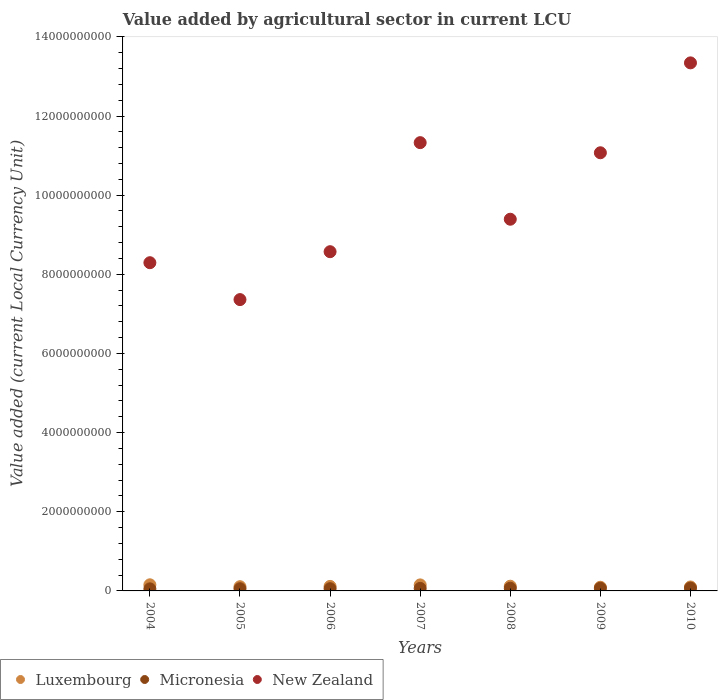How many different coloured dotlines are there?
Make the answer very short. 3. Is the number of dotlines equal to the number of legend labels?
Provide a short and direct response. Yes. What is the value added by agricultural sector in Micronesia in 2005?
Ensure brevity in your answer.  5.58e+07. Across all years, what is the maximum value added by agricultural sector in New Zealand?
Your answer should be very brief. 1.33e+1. Across all years, what is the minimum value added by agricultural sector in Luxembourg?
Your answer should be very brief. 9.30e+07. In which year was the value added by agricultural sector in Luxembourg maximum?
Your response must be concise. 2004. In which year was the value added by agricultural sector in Micronesia minimum?
Provide a short and direct response. 2004. What is the total value added by agricultural sector in Micronesia in the graph?
Give a very brief answer. 4.36e+08. What is the difference between the value added by agricultural sector in Micronesia in 2005 and that in 2006?
Your answer should be very brief. -9.00e+05. What is the difference between the value added by agricultural sector in Micronesia in 2005 and the value added by agricultural sector in New Zealand in 2007?
Provide a succinct answer. -1.13e+1. What is the average value added by agricultural sector in New Zealand per year?
Give a very brief answer. 9.91e+09. In the year 2007, what is the difference between the value added by agricultural sector in New Zealand and value added by agricultural sector in Micronesia?
Provide a succinct answer. 1.13e+1. In how many years, is the value added by agricultural sector in Micronesia greater than 5200000000 LCU?
Provide a short and direct response. 0. What is the ratio of the value added by agricultural sector in Micronesia in 2005 to that in 2008?
Your response must be concise. 0.82. What is the difference between the highest and the second highest value added by agricultural sector in Micronesia?
Ensure brevity in your answer.  2.90e+06. What is the difference between the highest and the lowest value added by agricultural sector in Luxembourg?
Your answer should be compact. 6.18e+07. In how many years, is the value added by agricultural sector in Luxembourg greater than the average value added by agricultural sector in Luxembourg taken over all years?
Your answer should be compact. 2. Does the value added by agricultural sector in Micronesia monotonically increase over the years?
Give a very brief answer. Yes. Is the value added by agricultural sector in Luxembourg strictly greater than the value added by agricultural sector in New Zealand over the years?
Ensure brevity in your answer.  No. How many dotlines are there?
Make the answer very short. 3. How many years are there in the graph?
Offer a terse response. 7. What is the difference between two consecutive major ticks on the Y-axis?
Give a very brief answer. 2.00e+09. Where does the legend appear in the graph?
Make the answer very short. Bottom left. What is the title of the graph?
Make the answer very short. Value added by agricultural sector in current LCU. What is the label or title of the Y-axis?
Give a very brief answer. Value added (current Local Currency Unit). What is the Value added (current Local Currency Unit) of Luxembourg in 2004?
Make the answer very short. 1.55e+08. What is the Value added (current Local Currency Unit) in Micronesia in 2004?
Make the answer very short. 5.26e+07. What is the Value added (current Local Currency Unit) of New Zealand in 2004?
Offer a very short reply. 8.29e+09. What is the Value added (current Local Currency Unit) of Luxembourg in 2005?
Provide a succinct answer. 1.07e+08. What is the Value added (current Local Currency Unit) of Micronesia in 2005?
Provide a succinct answer. 5.58e+07. What is the Value added (current Local Currency Unit) of New Zealand in 2005?
Your answer should be very brief. 7.36e+09. What is the Value added (current Local Currency Unit) of Luxembourg in 2006?
Provide a succinct answer. 1.14e+08. What is the Value added (current Local Currency Unit) of Micronesia in 2006?
Make the answer very short. 5.67e+07. What is the Value added (current Local Currency Unit) in New Zealand in 2006?
Provide a short and direct response. 8.57e+09. What is the Value added (current Local Currency Unit) of Luxembourg in 2007?
Keep it short and to the point. 1.52e+08. What is the Value added (current Local Currency Unit) in Micronesia in 2007?
Your answer should be compact. 6.37e+07. What is the Value added (current Local Currency Unit) in New Zealand in 2007?
Your answer should be compact. 1.13e+1. What is the Value added (current Local Currency Unit) in Luxembourg in 2008?
Ensure brevity in your answer.  1.19e+08. What is the Value added (current Local Currency Unit) in Micronesia in 2008?
Your answer should be very brief. 6.79e+07. What is the Value added (current Local Currency Unit) of New Zealand in 2008?
Your answer should be compact. 9.39e+09. What is the Value added (current Local Currency Unit) in Luxembourg in 2009?
Give a very brief answer. 9.30e+07. What is the Value added (current Local Currency Unit) of Micronesia in 2009?
Provide a succinct answer. 6.84e+07. What is the Value added (current Local Currency Unit) in New Zealand in 2009?
Give a very brief answer. 1.11e+1. What is the Value added (current Local Currency Unit) of Micronesia in 2010?
Offer a terse response. 7.13e+07. What is the Value added (current Local Currency Unit) of New Zealand in 2010?
Provide a short and direct response. 1.33e+1. Across all years, what is the maximum Value added (current Local Currency Unit) in Luxembourg?
Provide a short and direct response. 1.55e+08. Across all years, what is the maximum Value added (current Local Currency Unit) of Micronesia?
Your answer should be compact. 7.13e+07. Across all years, what is the maximum Value added (current Local Currency Unit) in New Zealand?
Your answer should be very brief. 1.33e+1. Across all years, what is the minimum Value added (current Local Currency Unit) of Luxembourg?
Your response must be concise. 9.30e+07. Across all years, what is the minimum Value added (current Local Currency Unit) in Micronesia?
Offer a very short reply. 5.26e+07. Across all years, what is the minimum Value added (current Local Currency Unit) in New Zealand?
Offer a very short reply. 7.36e+09. What is the total Value added (current Local Currency Unit) in Luxembourg in the graph?
Provide a succinct answer. 8.40e+08. What is the total Value added (current Local Currency Unit) of Micronesia in the graph?
Offer a very short reply. 4.36e+08. What is the total Value added (current Local Currency Unit) in New Zealand in the graph?
Provide a succinct answer. 6.94e+1. What is the difference between the Value added (current Local Currency Unit) of Luxembourg in 2004 and that in 2005?
Make the answer very short. 4.80e+07. What is the difference between the Value added (current Local Currency Unit) of Micronesia in 2004 and that in 2005?
Your answer should be compact. -3.20e+06. What is the difference between the Value added (current Local Currency Unit) in New Zealand in 2004 and that in 2005?
Ensure brevity in your answer.  9.32e+08. What is the difference between the Value added (current Local Currency Unit) of Luxembourg in 2004 and that in 2006?
Offer a terse response. 4.05e+07. What is the difference between the Value added (current Local Currency Unit) of Micronesia in 2004 and that in 2006?
Offer a very short reply. -4.10e+06. What is the difference between the Value added (current Local Currency Unit) of New Zealand in 2004 and that in 2006?
Provide a short and direct response. -2.78e+08. What is the difference between the Value added (current Local Currency Unit) in Luxembourg in 2004 and that in 2007?
Provide a succinct answer. 2.50e+06. What is the difference between the Value added (current Local Currency Unit) of Micronesia in 2004 and that in 2007?
Provide a succinct answer. -1.11e+07. What is the difference between the Value added (current Local Currency Unit) of New Zealand in 2004 and that in 2007?
Provide a short and direct response. -3.03e+09. What is the difference between the Value added (current Local Currency Unit) of Luxembourg in 2004 and that in 2008?
Keep it short and to the point. 3.59e+07. What is the difference between the Value added (current Local Currency Unit) of Micronesia in 2004 and that in 2008?
Offer a terse response. -1.53e+07. What is the difference between the Value added (current Local Currency Unit) of New Zealand in 2004 and that in 2008?
Keep it short and to the point. -1.10e+09. What is the difference between the Value added (current Local Currency Unit) in Luxembourg in 2004 and that in 2009?
Make the answer very short. 6.18e+07. What is the difference between the Value added (current Local Currency Unit) of Micronesia in 2004 and that in 2009?
Your response must be concise. -1.58e+07. What is the difference between the Value added (current Local Currency Unit) in New Zealand in 2004 and that in 2009?
Provide a short and direct response. -2.78e+09. What is the difference between the Value added (current Local Currency Unit) of Luxembourg in 2004 and that in 2010?
Provide a succinct answer. 5.48e+07. What is the difference between the Value added (current Local Currency Unit) in Micronesia in 2004 and that in 2010?
Your response must be concise. -1.87e+07. What is the difference between the Value added (current Local Currency Unit) in New Zealand in 2004 and that in 2010?
Your answer should be compact. -5.05e+09. What is the difference between the Value added (current Local Currency Unit) of Luxembourg in 2005 and that in 2006?
Offer a very short reply. -7.50e+06. What is the difference between the Value added (current Local Currency Unit) in Micronesia in 2005 and that in 2006?
Provide a succinct answer. -9.00e+05. What is the difference between the Value added (current Local Currency Unit) of New Zealand in 2005 and that in 2006?
Your response must be concise. -1.21e+09. What is the difference between the Value added (current Local Currency Unit) of Luxembourg in 2005 and that in 2007?
Your response must be concise. -4.55e+07. What is the difference between the Value added (current Local Currency Unit) of Micronesia in 2005 and that in 2007?
Keep it short and to the point. -7.90e+06. What is the difference between the Value added (current Local Currency Unit) of New Zealand in 2005 and that in 2007?
Make the answer very short. -3.97e+09. What is the difference between the Value added (current Local Currency Unit) of Luxembourg in 2005 and that in 2008?
Ensure brevity in your answer.  -1.21e+07. What is the difference between the Value added (current Local Currency Unit) in Micronesia in 2005 and that in 2008?
Ensure brevity in your answer.  -1.21e+07. What is the difference between the Value added (current Local Currency Unit) of New Zealand in 2005 and that in 2008?
Offer a terse response. -2.03e+09. What is the difference between the Value added (current Local Currency Unit) in Luxembourg in 2005 and that in 2009?
Your answer should be very brief. 1.38e+07. What is the difference between the Value added (current Local Currency Unit) in Micronesia in 2005 and that in 2009?
Your response must be concise. -1.26e+07. What is the difference between the Value added (current Local Currency Unit) of New Zealand in 2005 and that in 2009?
Give a very brief answer. -3.71e+09. What is the difference between the Value added (current Local Currency Unit) in Luxembourg in 2005 and that in 2010?
Offer a terse response. 6.80e+06. What is the difference between the Value added (current Local Currency Unit) of Micronesia in 2005 and that in 2010?
Give a very brief answer. -1.55e+07. What is the difference between the Value added (current Local Currency Unit) of New Zealand in 2005 and that in 2010?
Make the answer very short. -5.98e+09. What is the difference between the Value added (current Local Currency Unit) of Luxembourg in 2006 and that in 2007?
Offer a terse response. -3.80e+07. What is the difference between the Value added (current Local Currency Unit) in Micronesia in 2006 and that in 2007?
Give a very brief answer. -7.00e+06. What is the difference between the Value added (current Local Currency Unit) in New Zealand in 2006 and that in 2007?
Provide a succinct answer. -2.76e+09. What is the difference between the Value added (current Local Currency Unit) of Luxembourg in 2006 and that in 2008?
Your answer should be very brief. -4.60e+06. What is the difference between the Value added (current Local Currency Unit) of Micronesia in 2006 and that in 2008?
Offer a very short reply. -1.12e+07. What is the difference between the Value added (current Local Currency Unit) of New Zealand in 2006 and that in 2008?
Your answer should be compact. -8.20e+08. What is the difference between the Value added (current Local Currency Unit) of Luxembourg in 2006 and that in 2009?
Your answer should be compact. 2.13e+07. What is the difference between the Value added (current Local Currency Unit) in Micronesia in 2006 and that in 2009?
Provide a short and direct response. -1.17e+07. What is the difference between the Value added (current Local Currency Unit) of New Zealand in 2006 and that in 2009?
Your answer should be very brief. -2.50e+09. What is the difference between the Value added (current Local Currency Unit) in Luxembourg in 2006 and that in 2010?
Your answer should be very brief. 1.43e+07. What is the difference between the Value added (current Local Currency Unit) of Micronesia in 2006 and that in 2010?
Give a very brief answer. -1.46e+07. What is the difference between the Value added (current Local Currency Unit) in New Zealand in 2006 and that in 2010?
Your response must be concise. -4.77e+09. What is the difference between the Value added (current Local Currency Unit) of Luxembourg in 2007 and that in 2008?
Your response must be concise. 3.34e+07. What is the difference between the Value added (current Local Currency Unit) of Micronesia in 2007 and that in 2008?
Your answer should be very brief. -4.20e+06. What is the difference between the Value added (current Local Currency Unit) in New Zealand in 2007 and that in 2008?
Keep it short and to the point. 1.94e+09. What is the difference between the Value added (current Local Currency Unit) of Luxembourg in 2007 and that in 2009?
Offer a terse response. 5.93e+07. What is the difference between the Value added (current Local Currency Unit) in Micronesia in 2007 and that in 2009?
Your response must be concise. -4.70e+06. What is the difference between the Value added (current Local Currency Unit) of New Zealand in 2007 and that in 2009?
Keep it short and to the point. 2.56e+08. What is the difference between the Value added (current Local Currency Unit) in Luxembourg in 2007 and that in 2010?
Provide a short and direct response. 5.23e+07. What is the difference between the Value added (current Local Currency Unit) of Micronesia in 2007 and that in 2010?
Keep it short and to the point. -7.60e+06. What is the difference between the Value added (current Local Currency Unit) in New Zealand in 2007 and that in 2010?
Give a very brief answer. -2.02e+09. What is the difference between the Value added (current Local Currency Unit) of Luxembourg in 2008 and that in 2009?
Make the answer very short. 2.59e+07. What is the difference between the Value added (current Local Currency Unit) of Micronesia in 2008 and that in 2009?
Offer a very short reply. -5.00e+05. What is the difference between the Value added (current Local Currency Unit) in New Zealand in 2008 and that in 2009?
Make the answer very short. -1.68e+09. What is the difference between the Value added (current Local Currency Unit) of Luxembourg in 2008 and that in 2010?
Your response must be concise. 1.89e+07. What is the difference between the Value added (current Local Currency Unit) in Micronesia in 2008 and that in 2010?
Give a very brief answer. -3.40e+06. What is the difference between the Value added (current Local Currency Unit) of New Zealand in 2008 and that in 2010?
Provide a succinct answer. -3.95e+09. What is the difference between the Value added (current Local Currency Unit) of Luxembourg in 2009 and that in 2010?
Your answer should be compact. -7.00e+06. What is the difference between the Value added (current Local Currency Unit) of Micronesia in 2009 and that in 2010?
Offer a terse response. -2.90e+06. What is the difference between the Value added (current Local Currency Unit) in New Zealand in 2009 and that in 2010?
Provide a succinct answer. -2.27e+09. What is the difference between the Value added (current Local Currency Unit) of Luxembourg in 2004 and the Value added (current Local Currency Unit) of Micronesia in 2005?
Provide a short and direct response. 9.90e+07. What is the difference between the Value added (current Local Currency Unit) in Luxembourg in 2004 and the Value added (current Local Currency Unit) in New Zealand in 2005?
Your answer should be compact. -7.21e+09. What is the difference between the Value added (current Local Currency Unit) of Micronesia in 2004 and the Value added (current Local Currency Unit) of New Zealand in 2005?
Your response must be concise. -7.31e+09. What is the difference between the Value added (current Local Currency Unit) of Luxembourg in 2004 and the Value added (current Local Currency Unit) of Micronesia in 2006?
Provide a succinct answer. 9.81e+07. What is the difference between the Value added (current Local Currency Unit) of Luxembourg in 2004 and the Value added (current Local Currency Unit) of New Zealand in 2006?
Offer a terse response. -8.42e+09. What is the difference between the Value added (current Local Currency Unit) in Micronesia in 2004 and the Value added (current Local Currency Unit) in New Zealand in 2006?
Make the answer very short. -8.52e+09. What is the difference between the Value added (current Local Currency Unit) of Luxembourg in 2004 and the Value added (current Local Currency Unit) of Micronesia in 2007?
Offer a terse response. 9.11e+07. What is the difference between the Value added (current Local Currency Unit) in Luxembourg in 2004 and the Value added (current Local Currency Unit) in New Zealand in 2007?
Ensure brevity in your answer.  -1.12e+1. What is the difference between the Value added (current Local Currency Unit) in Micronesia in 2004 and the Value added (current Local Currency Unit) in New Zealand in 2007?
Your response must be concise. -1.13e+1. What is the difference between the Value added (current Local Currency Unit) in Luxembourg in 2004 and the Value added (current Local Currency Unit) in Micronesia in 2008?
Offer a very short reply. 8.69e+07. What is the difference between the Value added (current Local Currency Unit) in Luxembourg in 2004 and the Value added (current Local Currency Unit) in New Zealand in 2008?
Make the answer very short. -9.24e+09. What is the difference between the Value added (current Local Currency Unit) of Micronesia in 2004 and the Value added (current Local Currency Unit) of New Zealand in 2008?
Your answer should be compact. -9.34e+09. What is the difference between the Value added (current Local Currency Unit) of Luxembourg in 2004 and the Value added (current Local Currency Unit) of Micronesia in 2009?
Offer a terse response. 8.64e+07. What is the difference between the Value added (current Local Currency Unit) in Luxembourg in 2004 and the Value added (current Local Currency Unit) in New Zealand in 2009?
Provide a short and direct response. -1.09e+1. What is the difference between the Value added (current Local Currency Unit) in Micronesia in 2004 and the Value added (current Local Currency Unit) in New Zealand in 2009?
Make the answer very short. -1.10e+1. What is the difference between the Value added (current Local Currency Unit) of Luxembourg in 2004 and the Value added (current Local Currency Unit) of Micronesia in 2010?
Your answer should be very brief. 8.35e+07. What is the difference between the Value added (current Local Currency Unit) in Luxembourg in 2004 and the Value added (current Local Currency Unit) in New Zealand in 2010?
Ensure brevity in your answer.  -1.32e+1. What is the difference between the Value added (current Local Currency Unit) in Micronesia in 2004 and the Value added (current Local Currency Unit) in New Zealand in 2010?
Give a very brief answer. -1.33e+1. What is the difference between the Value added (current Local Currency Unit) of Luxembourg in 2005 and the Value added (current Local Currency Unit) of Micronesia in 2006?
Your response must be concise. 5.01e+07. What is the difference between the Value added (current Local Currency Unit) of Luxembourg in 2005 and the Value added (current Local Currency Unit) of New Zealand in 2006?
Ensure brevity in your answer.  -8.46e+09. What is the difference between the Value added (current Local Currency Unit) in Micronesia in 2005 and the Value added (current Local Currency Unit) in New Zealand in 2006?
Provide a succinct answer. -8.52e+09. What is the difference between the Value added (current Local Currency Unit) of Luxembourg in 2005 and the Value added (current Local Currency Unit) of Micronesia in 2007?
Ensure brevity in your answer.  4.31e+07. What is the difference between the Value added (current Local Currency Unit) in Luxembourg in 2005 and the Value added (current Local Currency Unit) in New Zealand in 2007?
Keep it short and to the point. -1.12e+1. What is the difference between the Value added (current Local Currency Unit) of Micronesia in 2005 and the Value added (current Local Currency Unit) of New Zealand in 2007?
Provide a succinct answer. -1.13e+1. What is the difference between the Value added (current Local Currency Unit) in Luxembourg in 2005 and the Value added (current Local Currency Unit) in Micronesia in 2008?
Keep it short and to the point. 3.89e+07. What is the difference between the Value added (current Local Currency Unit) in Luxembourg in 2005 and the Value added (current Local Currency Unit) in New Zealand in 2008?
Offer a terse response. -9.29e+09. What is the difference between the Value added (current Local Currency Unit) in Micronesia in 2005 and the Value added (current Local Currency Unit) in New Zealand in 2008?
Your answer should be very brief. -9.34e+09. What is the difference between the Value added (current Local Currency Unit) in Luxembourg in 2005 and the Value added (current Local Currency Unit) in Micronesia in 2009?
Offer a terse response. 3.84e+07. What is the difference between the Value added (current Local Currency Unit) in Luxembourg in 2005 and the Value added (current Local Currency Unit) in New Zealand in 2009?
Make the answer very short. -1.10e+1. What is the difference between the Value added (current Local Currency Unit) in Micronesia in 2005 and the Value added (current Local Currency Unit) in New Zealand in 2009?
Give a very brief answer. -1.10e+1. What is the difference between the Value added (current Local Currency Unit) in Luxembourg in 2005 and the Value added (current Local Currency Unit) in Micronesia in 2010?
Keep it short and to the point. 3.55e+07. What is the difference between the Value added (current Local Currency Unit) in Luxembourg in 2005 and the Value added (current Local Currency Unit) in New Zealand in 2010?
Ensure brevity in your answer.  -1.32e+1. What is the difference between the Value added (current Local Currency Unit) of Micronesia in 2005 and the Value added (current Local Currency Unit) of New Zealand in 2010?
Offer a very short reply. -1.33e+1. What is the difference between the Value added (current Local Currency Unit) in Luxembourg in 2006 and the Value added (current Local Currency Unit) in Micronesia in 2007?
Provide a short and direct response. 5.06e+07. What is the difference between the Value added (current Local Currency Unit) of Luxembourg in 2006 and the Value added (current Local Currency Unit) of New Zealand in 2007?
Your response must be concise. -1.12e+1. What is the difference between the Value added (current Local Currency Unit) in Micronesia in 2006 and the Value added (current Local Currency Unit) in New Zealand in 2007?
Ensure brevity in your answer.  -1.13e+1. What is the difference between the Value added (current Local Currency Unit) in Luxembourg in 2006 and the Value added (current Local Currency Unit) in Micronesia in 2008?
Provide a short and direct response. 4.64e+07. What is the difference between the Value added (current Local Currency Unit) of Luxembourg in 2006 and the Value added (current Local Currency Unit) of New Zealand in 2008?
Offer a terse response. -9.28e+09. What is the difference between the Value added (current Local Currency Unit) in Micronesia in 2006 and the Value added (current Local Currency Unit) in New Zealand in 2008?
Ensure brevity in your answer.  -9.34e+09. What is the difference between the Value added (current Local Currency Unit) in Luxembourg in 2006 and the Value added (current Local Currency Unit) in Micronesia in 2009?
Keep it short and to the point. 4.59e+07. What is the difference between the Value added (current Local Currency Unit) of Luxembourg in 2006 and the Value added (current Local Currency Unit) of New Zealand in 2009?
Keep it short and to the point. -1.10e+1. What is the difference between the Value added (current Local Currency Unit) in Micronesia in 2006 and the Value added (current Local Currency Unit) in New Zealand in 2009?
Give a very brief answer. -1.10e+1. What is the difference between the Value added (current Local Currency Unit) in Luxembourg in 2006 and the Value added (current Local Currency Unit) in Micronesia in 2010?
Your answer should be very brief. 4.30e+07. What is the difference between the Value added (current Local Currency Unit) in Luxembourg in 2006 and the Value added (current Local Currency Unit) in New Zealand in 2010?
Your answer should be very brief. -1.32e+1. What is the difference between the Value added (current Local Currency Unit) of Micronesia in 2006 and the Value added (current Local Currency Unit) of New Zealand in 2010?
Offer a terse response. -1.33e+1. What is the difference between the Value added (current Local Currency Unit) of Luxembourg in 2007 and the Value added (current Local Currency Unit) of Micronesia in 2008?
Your response must be concise. 8.44e+07. What is the difference between the Value added (current Local Currency Unit) in Luxembourg in 2007 and the Value added (current Local Currency Unit) in New Zealand in 2008?
Your answer should be very brief. -9.24e+09. What is the difference between the Value added (current Local Currency Unit) of Micronesia in 2007 and the Value added (current Local Currency Unit) of New Zealand in 2008?
Your response must be concise. -9.33e+09. What is the difference between the Value added (current Local Currency Unit) of Luxembourg in 2007 and the Value added (current Local Currency Unit) of Micronesia in 2009?
Your answer should be compact. 8.39e+07. What is the difference between the Value added (current Local Currency Unit) of Luxembourg in 2007 and the Value added (current Local Currency Unit) of New Zealand in 2009?
Ensure brevity in your answer.  -1.09e+1. What is the difference between the Value added (current Local Currency Unit) of Micronesia in 2007 and the Value added (current Local Currency Unit) of New Zealand in 2009?
Provide a succinct answer. -1.10e+1. What is the difference between the Value added (current Local Currency Unit) in Luxembourg in 2007 and the Value added (current Local Currency Unit) in Micronesia in 2010?
Keep it short and to the point. 8.10e+07. What is the difference between the Value added (current Local Currency Unit) of Luxembourg in 2007 and the Value added (current Local Currency Unit) of New Zealand in 2010?
Give a very brief answer. -1.32e+1. What is the difference between the Value added (current Local Currency Unit) of Micronesia in 2007 and the Value added (current Local Currency Unit) of New Zealand in 2010?
Provide a short and direct response. -1.33e+1. What is the difference between the Value added (current Local Currency Unit) of Luxembourg in 2008 and the Value added (current Local Currency Unit) of Micronesia in 2009?
Give a very brief answer. 5.05e+07. What is the difference between the Value added (current Local Currency Unit) in Luxembourg in 2008 and the Value added (current Local Currency Unit) in New Zealand in 2009?
Offer a very short reply. -1.10e+1. What is the difference between the Value added (current Local Currency Unit) in Micronesia in 2008 and the Value added (current Local Currency Unit) in New Zealand in 2009?
Make the answer very short. -1.10e+1. What is the difference between the Value added (current Local Currency Unit) in Luxembourg in 2008 and the Value added (current Local Currency Unit) in Micronesia in 2010?
Ensure brevity in your answer.  4.76e+07. What is the difference between the Value added (current Local Currency Unit) of Luxembourg in 2008 and the Value added (current Local Currency Unit) of New Zealand in 2010?
Offer a very short reply. -1.32e+1. What is the difference between the Value added (current Local Currency Unit) in Micronesia in 2008 and the Value added (current Local Currency Unit) in New Zealand in 2010?
Offer a terse response. -1.33e+1. What is the difference between the Value added (current Local Currency Unit) of Luxembourg in 2009 and the Value added (current Local Currency Unit) of Micronesia in 2010?
Offer a very short reply. 2.17e+07. What is the difference between the Value added (current Local Currency Unit) of Luxembourg in 2009 and the Value added (current Local Currency Unit) of New Zealand in 2010?
Your response must be concise. -1.32e+1. What is the difference between the Value added (current Local Currency Unit) in Micronesia in 2009 and the Value added (current Local Currency Unit) in New Zealand in 2010?
Make the answer very short. -1.33e+1. What is the average Value added (current Local Currency Unit) in Luxembourg per year?
Offer a very short reply. 1.20e+08. What is the average Value added (current Local Currency Unit) in Micronesia per year?
Offer a very short reply. 6.23e+07. What is the average Value added (current Local Currency Unit) of New Zealand per year?
Offer a very short reply. 9.91e+09. In the year 2004, what is the difference between the Value added (current Local Currency Unit) in Luxembourg and Value added (current Local Currency Unit) in Micronesia?
Give a very brief answer. 1.02e+08. In the year 2004, what is the difference between the Value added (current Local Currency Unit) in Luxembourg and Value added (current Local Currency Unit) in New Zealand?
Provide a short and direct response. -8.14e+09. In the year 2004, what is the difference between the Value added (current Local Currency Unit) of Micronesia and Value added (current Local Currency Unit) of New Zealand?
Your response must be concise. -8.24e+09. In the year 2005, what is the difference between the Value added (current Local Currency Unit) in Luxembourg and Value added (current Local Currency Unit) in Micronesia?
Ensure brevity in your answer.  5.10e+07. In the year 2005, what is the difference between the Value added (current Local Currency Unit) in Luxembourg and Value added (current Local Currency Unit) in New Zealand?
Keep it short and to the point. -7.25e+09. In the year 2005, what is the difference between the Value added (current Local Currency Unit) in Micronesia and Value added (current Local Currency Unit) in New Zealand?
Your response must be concise. -7.31e+09. In the year 2006, what is the difference between the Value added (current Local Currency Unit) in Luxembourg and Value added (current Local Currency Unit) in Micronesia?
Make the answer very short. 5.76e+07. In the year 2006, what is the difference between the Value added (current Local Currency Unit) in Luxembourg and Value added (current Local Currency Unit) in New Zealand?
Ensure brevity in your answer.  -8.46e+09. In the year 2006, what is the difference between the Value added (current Local Currency Unit) of Micronesia and Value added (current Local Currency Unit) of New Zealand?
Your response must be concise. -8.51e+09. In the year 2007, what is the difference between the Value added (current Local Currency Unit) of Luxembourg and Value added (current Local Currency Unit) of Micronesia?
Offer a very short reply. 8.86e+07. In the year 2007, what is the difference between the Value added (current Local Currency Unit) of Luxembourg and Value added (current Local Currency Unit) of New Zealand?
Offer a terse response. -1.12e+1. In the year 2007, what is the difference between the Value added (current Local Currency Unit) in Micronesia and Value added (current Local Currency Unit) in New Zealand?
Provide a succinct answer. -1.13e+1. In the year 2008, what is the difference between the Value added (current Local Currency Unit) in Luxembourg and Value added (current Local Currency Unit) in Micronesia?
Ensure brevity in your answer.  5.10e+07. In the year 2008, what is the difference between the Value added (current Local Currency Unit) of Luxembourg and Value added (current Local Currency Unit) of New Zealand?
Ensure brevity in your answer.  -9.27e+09. In the year 2008, what is the difference between the Value added (current Local Currency Unit) of Micronesia and Value added (current Local Currency Unit) of New Zealand?
Offer a terse response. -9.32e+09. In the year 2009, what is the difference between the Value added (current Local Currency Unit) of Luxembourg and Value added (current Local Currency Unit) of Micronesia?
Keep it short and to the point. 2.46e+07. In the year 2009, what is the difference between the Value added (current Local Currency Unit) in Luxembourg and Value added (current Local Currency Unit) in New Zealand?
Provide a short and direct response. -1.10e+1. In the year 2009, what is the difference between the Value added (current Local Currency Unit) in Micronesia and Value added (current Local Currency Unit) in New Zealand?
Give a very brief answer. -1.10e+1. In the year 2010, what is the difference between the Value added (current Local Currency Unit) of Luxembourg and Value added (current Local Currency Unit) of Micronesia?
Offer a very short reply. 2.87e+07. In the year 2010, what is the difference between the Value added (current Local Currency Unit) in Luxembourg and Value added (current Local Currency Unit) in New Zealand?
Make the answer very short. -1.32e+1. In the year 2010, what is the difference between the Value added (current Local Currency Unit) in Micronesia and Value added (current Local Currency Unit) in New Zealand?
Your response must be concise. -1.33e+1. What is the ratio of the Value added (current Local Currency Unit) of Luxembourg in 2004 to that in 2005?
Ensure brevity in your answer.  1.45. What is the ratio of the Value added (current Local Currency Unit) in Micronesia in 2004 to that in 2005?
Ensure brevity in your answer.  0.94. What is the ratio of the Value added (current Local Currency Unit) in New Zealand in 2004 to that in 2005?
Provide a succinct answer. 1.13. What is the ratio of the Value added (current Local Currency Unit) in Luxembourg in 2004 to that in 2006?
Make the answer very short. 1.35. What is the ratio of the Value added (current Local Currency Unit) of Micronesia in 2004 to that in 2006?
Ensure brevity in your answer.  0.93. What is the ratio of the Value added (current Local Currency Unit) of New Zealand in 2004 to that in 2006?
Offer a very short reply. 0.97. What is the ratio of the Value added (current Local Currency Unit) of Luxembourg in 2004 to that in 2007?
Give a very brief answer. 1.02. What is the ratio of the Value added (current Local Currency Unit) of Micronesia in 2004 to that in 2007?
Offer a very short reply. 0.83. What is the ratio of the Value added (current Local Currency Unit) of New Zealand in 2004 to that in 2007?
Keep it short and to the point. 0.73. What is the ratio of the Value added (current Local Currency Unit) of Luxembourg in 2004 to that in 2008?
Offer a terse response. 1.3. What is the ratio of the Value added (current Local Currency Unit) of Micronesia in 2004 to that in 2008?
Offer a very short reply. 0.77. What is the ratio of the Value added (current Local Currency Unit) of New Zealand in 2004 to that in 2008?
Offer a terse response. 0.88. What is the ratio of the Value added (current Local Currency Unit) of Luxembourg in 2004 to that in 2009?
Provide a short and direct response. 1.66. What is the ratio of the Value added (current Local Currency Unit) of Micronesia in 2004 to that in 2009?
Offer a very short reply. 0.77. What is the ratio of the Value added (current Local Currency Unit) in New Zealand in 2004 to that in 2009?
Offer a very short reply. 0.75. What is the ratio of the Value added (current Local Currency Unit) in Luxembourg in 2004 to that in 2010?
Your response must be concise. 1.55. What is the ratio of the Value added (current Local Currency Unit) of Micronesia in 2004 to that in 2010?
Provide a short and direct response. 0.74. What is the ratio of the Value added (current Local Currency Unit) of New Zealand in 2004 to that in 2010?
Keep it short and to the point. 0.62. What is the ratio of the Value added (current Local Currency Unit) in Luxembourg in 2005 to that in 2006?
Make the answer very short. 0.93. What is the ratio of the Value added (current Local Currency Unit) in Micronesia in 2005 to that in 2006?
Offer a terse response. 0.98. What is the ratio of the Value added (current Local Currency Unit) in New Zealand in 2005 to that in 2006?
Provide a short and direct response. 0.86. What is the ratio of the Value added (current Local Currency Unit) of Luxembourg in 2005 to that in 2007?
Keep it short and to the point. 0.7. What is the ratio of the Value added (current Local Currency Unit) of Micronesia in 2005 to that in 2007?
Your response must be concise. 0.88. What is the ratio of the Value added (current Local Currency Unit) of New Zealand in 2005 to that in 2007?
Provide a succinct answer. 0.65. What is the ratio of the Value added (current Local Currency Unit) of Luxembourg in 2005 to that in 2008?
Offer a terse response. 0.9. What is the ratio of the Value added (current Local Currency Unit) of Micronesia in 2005 to that in 2008?
Give a very brief answer. 0.82. What is the ratio of the Value added (current Local Currency Unit) of New Zealand in 2005 to that in 2008?
Provide a short and direct response. 0.78. What is the ratio of the Value added (current Local Currency Unit) in Luxembourg in 2005 to that in 2009?
Keep it short and to the point. 1.15. What is the ratio of the Value added (current Local Currency Unit) of Micronesia in 2005 to that in 2009?
Your answer should be very brief. 0.82. What is the ratio of the Value added (current Local Currency Unit) of New Zealand in 2005 to that in 2009?
Ensure brevity in your answer.  0.66. What is the ratio of the Value added (current Local Currency Unit) in Luxembourg in 2005 to that in 2010?
Offer a terse response. 1.07. What is the ratio of the Value added (current Local Currency Unit) in Micronesia in 2005 to that in 2010?
Offer a terse response. 0.78. What is the ratio of the Value added (current Local Currency Unit) of New Zealand in 2005 to that in 2010?
Ensure brevity in your answer.  0.55. What is the ratio of the Value added (current Local Currency Unit) of Luxembourg in 2006 to that in 2007?
Make the answer very short. 0.75. What is the ratio of the Value added (current Local Currency Unit) of Micronesia in 2006 to that in 2007?
Offer a terse response. 0.89. What is the ratio of the Value added (current Local Currency Unit) of New Zealand in 2006 to that in 2007?
Offer a terse response. 0.76. What is the ratio of the Value added (current Local Currency Unit) in Luxembourg in 2006 to that in 2008?
Offer a terse response. 0.96. What is the ratio of the Value added (current Local Currency Unit) in Micronesia in 2006 to that in 2008?
Provide a short and direct response. 0.84. What is the ratio of the Value added (current Local Currency Unit) of New Zealand in 2006 to that in 2008?
Your response must be concise. 0.91. What is the ratio of the Value added (current Local Currency Unit) in Luxembourg in 2006 to that in 2009?
Offer a terse response. 1.23. What is the ratio of the Value added (current Local Currency Unit) in Micronesia in 2006 to that in 2009?
Provide a short and direct response. 0.83. What is the ratio of the Value added (current Local Currency Unit) in New Zealand in 2006 to that in 2009?
Your answer should be very brief. 0.77. What is the ratio of the Value added (current Local Currency Unit) in Luxembourg in 2006 to that in 2010?
Keep it short and to the point. 1.14. What is the ratio of the Value added (current Local Currency Unit) in Micronesia in 2006 to that in 2010?
Your answer should be compact. 0.8. What is the ratio of the Value added (current Local Currency Unit) in New Zealand in 2006 to that in 2010?
Keep it short and to the point. 0.64. What is the ratio of the Value added (current Local Currency Unit) in Luxembourg in 2007 to that in 2008?
Offer a terse response. 1.28. What is the ratio of the Value added (current Local Currency Unit) in Micronesia in 2007 to that in 2008?
Provide a succinct answer. 0.94. What is the ratio of the Value added (current Local Currency Unit) in New Zealand in 2007 to that in 2008?
Ensure brevity in your answer.  1.21. What is the ratio of the Value added (current Local Currency Unit) of Luxembourg in 2007 to that in 2009?
Offer a very short reply. 1.64. What is the ratio of the Value added (current Local Currency Unit) in Micronesia in 2007 to that in 2009?
Your answer should be compact. 0.93. What is the ratio of the Value added (current Local Currency Unit) in New Zealand in 2007 to that in 2009?
Provide a short and direct response. 1.02. What is the ratio of the Value added (current Local Currency Unit) of Luxembourg in 2007 to that in 2010?
Keep it short and to the point. 1.52. What is the ratio of the Value added (current Local Currency Unit) of Micronesia in 2007 to that in 2010?
Provide a succinct answer. 0.89. What is the ratio of the Value added (current Local Currency Unit) of New Zealand in 2007 to that in 2010?
Provide a short and direct response. 0.85. What is the ratio of the Value added (current Local Currency Unit) of Luxembourg in 2008 to that in 2009?
Provide a short and direct response. 1.28. What is the ratio of the Value added (current Local Currency Unit) of Micronesia in 2008 to that in 2009?
Your answer should be very brief. 0.99. What is the ratio of the Value added (current Local Currency Unit) of New Zealand in 2008 to that in 2009?
Keep it short and to the point. 0.85. What is the ratio of the Value added (current Local Currency Unit) of Luxembourg in 2008 to that in 2010?
Offer a terse response. 1.19. What is the ratio of the Value added (current Local Currency Unit) of Micronesia in 2008 to that in 2010?
Make the answer very short. 0.95. What is the ratio of the Value added (current Local Currency Unit) in New Zealand in 2008 to that in 2010?
Keep it short and to the point. 0.7. What is the ratio of the Value added (current Local Currency Unit) in Micronesia in 2009 to that in 2010?
Offer a very short reply. 0.96. What is the ratio of the Value added (current Local Currency Unit) of New Zealand in 2009 to that in 2010?
Offer a terse response. 0.83. What is the difference between the highest and the second highest Value added (current Local Currency Unit) in Luxembourg?
Keep it short and to the point. 2.50e+06. What is the difference between the highest and the second highest Value added (current Local Currency Unit) in Micronesia?
Offer a very short reply. 2.90e+06. What is the difference between the highest and the second highest Value added (current Local Currency Unit) in New Zealand?
Your answer should be very brief. 2.02e+09. What is the difference between the highest and the lowest Value added (current Local Currency Unit) in Luxembourg?
Provide a succinct answer. 6.18e+07. What is the difference between the highest and the lowest Value added (current Local Currency Unit) in Micronesia?
Offer a very short reply. 1.87e+07. What is the difference between the highest and the lowest Value added (current Local Currency Unit) in New Zealand?
Keep it short and to the point. 5.98e+09. 